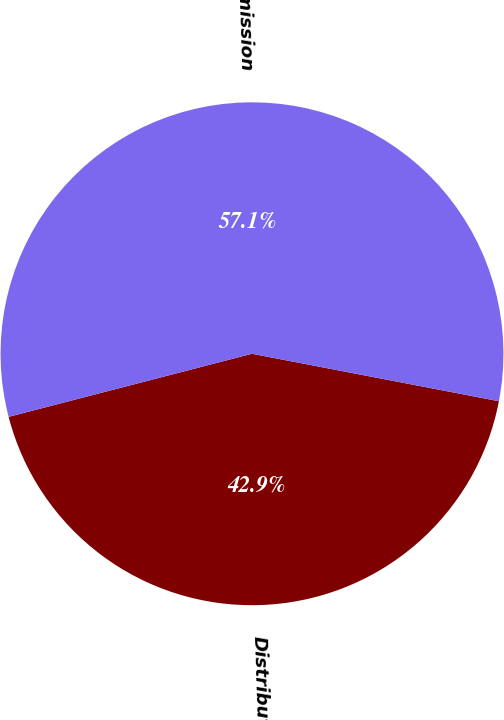Convert chart to OTSL. <chart><loc_0><loc_0><loc_500><loc_500><pie_chart><fcel>Distribution<fcel>Transmission<nl><fcel>42.94%<fcel>57.06%<nl></chart> 